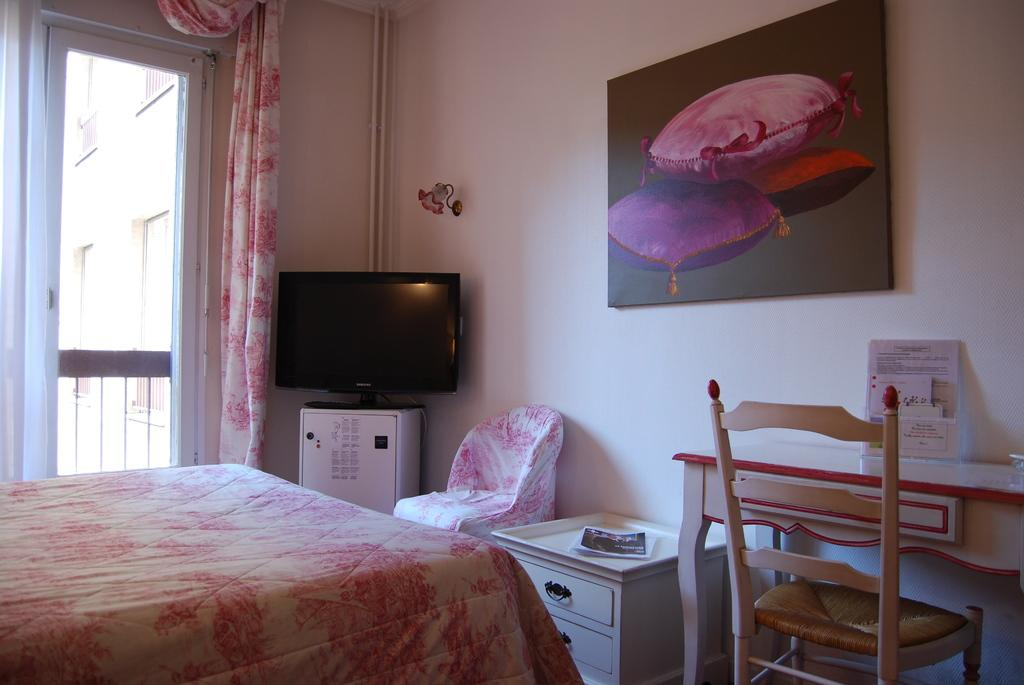What type of furniture is present in the image? There is a table, a chair, and another table in the image. What is the color of the table? The table is white and pink in color. What is located beside the table? There is a door beside the table. What electronic device is visible in the image? There is a television in the image. What is hanging on the wall in front of the table? There is a picture on the wall in front of the table. What type of government is depicted in the picture on the wall? There is no government depicted in the picture on the wall; it is not mentioned in the provided facts. Is the person's father sitting in the chair in the image? There is no person or father mentioned in the provided facts, so it cannot be determined if someone is sitting in the chair. 